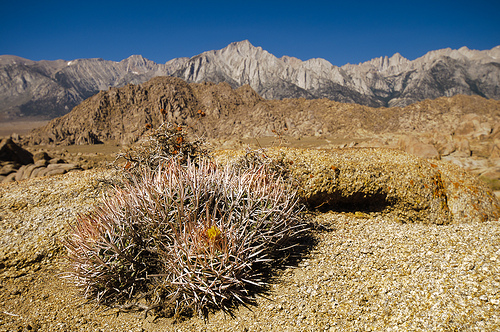<image>
Is the mountain above the sky? No. The mountain is not positioned above the sky. The vertical arrangement shows a different relationship. 